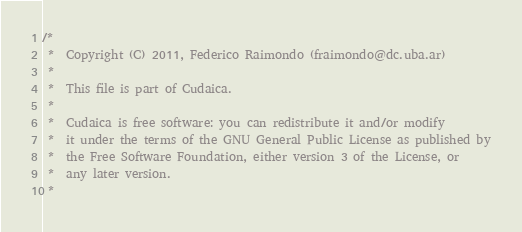Convert code to text. <code><loc_0><loc_0><loc_500><loc_500><_Cuda_>/*	
 *	Copyright (C) 2011, Federico Raimondo (fraimondo@dc.uba.ar)
 *	
 *	This file is part of Cudaica.
 *
 *  Cudaica is free software: you can redistribute it and/or modify
 *  it under the terms of the GNU General Public License as published by
 *  the Free Software Foundation, either version 3 of the License, or
 *  any later version.
 *</code> 